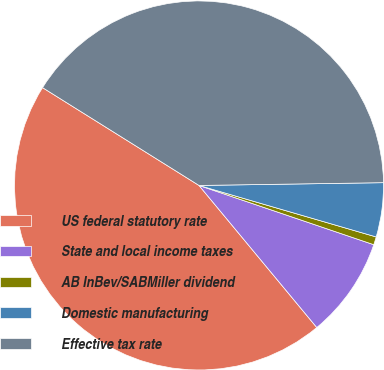<chart> <loc_0><loc_0><loc_500><loc_500><pie_chart><fcel>US federal statutory rate<fcel>State and local income taxes<fcel>AB InBev/SABMiller dividend<fcel>Domestic manufacturing<fcel>Effective tax rate<nl><fcel>44.9%<fcel>8.78%<fcel>0.7%<fcel>4.74%<fcel>40.86%<nl></chart> 